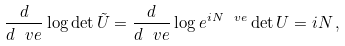Convert formula to latex. <formula><loc_0><loc_0><loc_500><loc_500>\frac { d } { d \ v e } \log \det \tilde { U } = \frac { d } { d \ v e } \log e ^ { i N \ v e } \det U = i N \, ,</formula> 